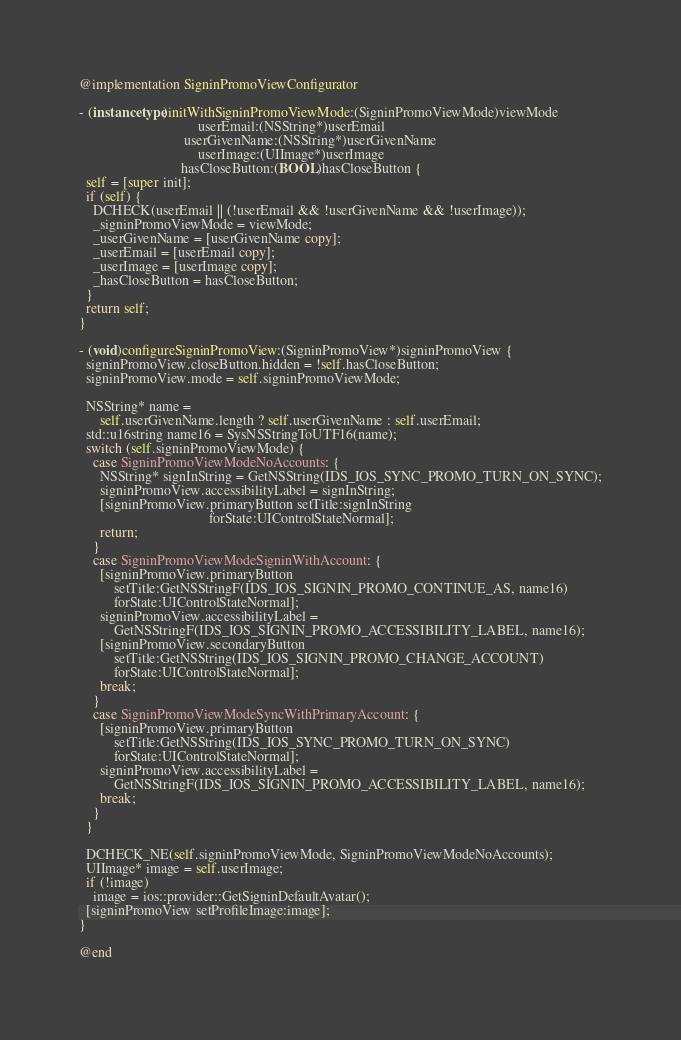<code> <loc_0><loc_0><loc_500><loc_500><_ObjectiveC_>
@implementation SigninPromoViewConfigurator

- (instancetype)initWithSigninPromoViewMode:(SigninPromoViewMode)viewMode
                                  userEmail:(NSString*)userEmail
                              userGivenName:(NSString*)userGivenName
                                  userImage:(UIImage*)userImage
                             hasCloseButton:(BOOL)hasCloseButton {
  self = [super init];
  if (self) {
    DCHECK(userEmail || (!userEmail && !userGivenName && !userImage));
    _signinPromoViewMode = viewMode;
    _userGivenName = [userGivenName copy];
    _userEmail = [userEmail copy];
    _userImage = [userImage copy];
    _hasCloseButton = hasCloseButton;
  }
  return self;
}

- (void)configureSigninPromoView:(SigninPromoView*)signinPromoView {
  signinPromoView.closeButton.hidden = !self.hasCloseButton;
  signinPromoView.mode = self.signinPromoViewMode;

  NSString* name =
      self.userGivenName.length ? self.userGivenName : self.userEmail;
  std::u16string name16 = SysNSStringToUTF16(name);
  switch (self.signinPromoViewMode) {
    case SigninPromoViewModeNoAccounts: {
      NSString* signInString = GetNSString(IDS_IOS_SYNC_PROMO_TURN_ON_SYNC);
      signinPromoView.accessibilityLabel = signInString;
      [signinPromoView.primaryButton setTitle:signInString
                                     forState:UIControlStateNormal];
      return;
    }
    case SigninPromoViewModeSigninWithAccount: {
      [signinPromoView.primaryButton
          setTitle:GetNSStringF(IDS_IOS_SIGNIN_PROMO_CONTINUE_AS, name16)
          forState:UIControlStateNormal];
      signinPromoView.accessibilityLabel =
          GetNSStringF(IDS_IOS_SIGNIN_PROMO_ACCESSIBILITY_LABEL, name16);
      [signinPromoView.secondaryButton
          setTitle:GetNSString(IDS_IOS_SIGNIN_PROMO_CHANGE_ACCOUNT)
          forState:UIControlStateNormal];
      break;
    }
    case SigninPromoViewModeSyncWithPrimaryAccount: {
      [signinPromoView.primaryButton
          setTitle:GetNSString(IDS_IOS_SYNC_PROMO_TURN_ON_SYNC)
          forState:UIControlStateNormal];
      signinPromoView.accessibilityLabel =
          GetNSStringF(IDS_IOS_SIGNIN_PROMO_ACCESSIBILITY_LABEL, name16);
      break;
    }
  }

  DCHECK_NE(self.signinPromoViewMode, SigninPromoViewModeNoAccounts);
  UIImage* image = self.userImage;
  if (!image)
    image = ios::provider::GetSigninDefaultAvatar();
  [signinPromoView setProfileImage:image];
}

@end
</code> 